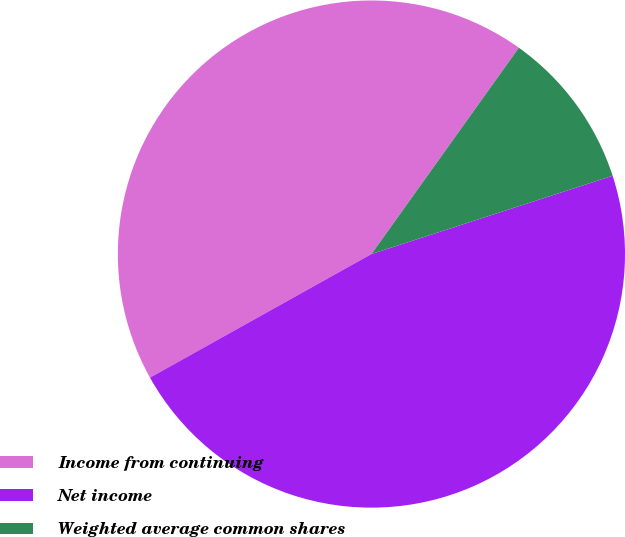<chart> <loc_0><loc_0><loc_500><loc_500><pie_chart><fcel>Income from continuing<fcel>Net income<fcel>Weighted average common shares<nl><fcel>42.98%<fcel>46.9%<fcel>10.13%<nl></chart> 